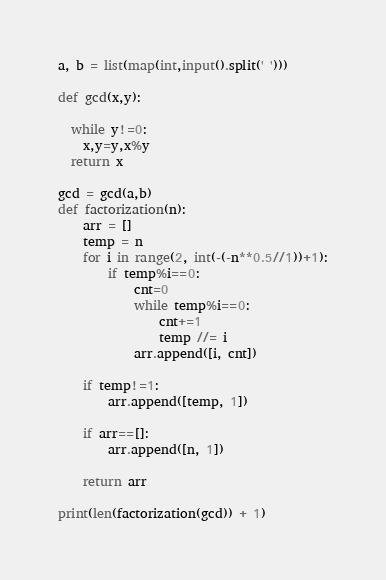<code> <loc_0><loc_0><loc_500><loc_500><_Python_>a, b = list(map(int,input().split(' ')))

def gcd(x,y):

  while y!=0:
    x,y=y,x%y
  return x

gcd = gcd(a,b)
def factorization(n):
    arr = []
    temp = n
    for i in range(2, int(-(-n**0.5//1))+1):
        if temp%i==0:
            cnt=0
            while temp%i==0:
                cnt+=1
                temp //= i
            arr.append([i, cnt])

    if temp!=1:
        arr.append([temp, 1])

    if arr==[]:
        arr.append([n, 1])

    return arr

print(len(factorization(gcd)) + 1)</code> 